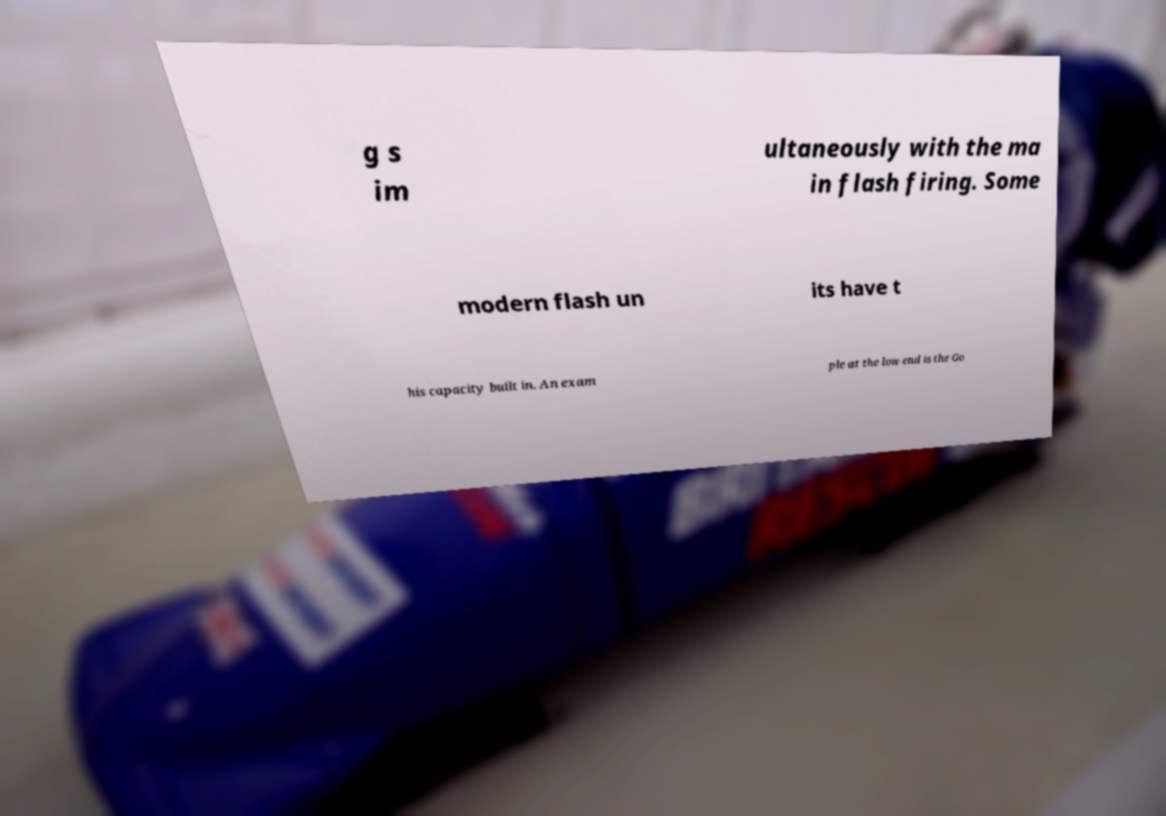Please read and relay the text visible in this image. What does it say? g s im ultaneously with the ma in flash firing. Some modern flash un its have t his capacity built in. An exam ple at the low end is the Go 